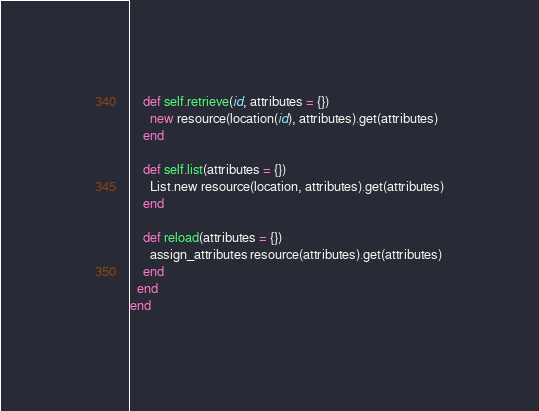<code> <loc_0><loc_0><loc_500><loc_500><_Ruby_>
    def self.retrieve(id, attributes = {})
      new resource(location(id), attributes).get(attributes)
    end

    def self.list(attributes = {})
      List.new resource(location, attributes).get(attributes)
    end

    def reload(attributes = {})
      assign_attributes resource(attributes).get(attributes)
    end
  end
end
</code> 